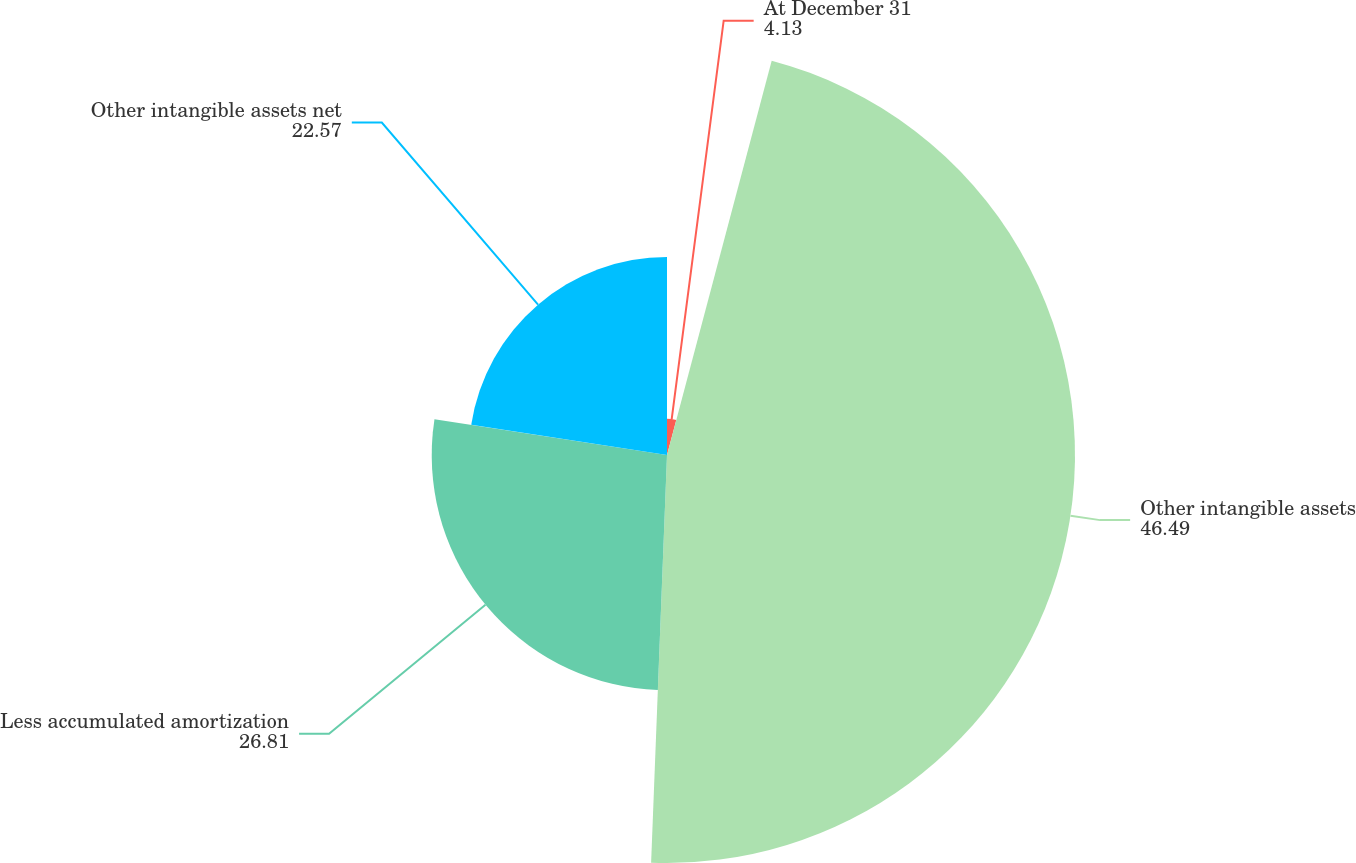Convert chart to OTSL. <chart><loc_0><loc_0><loc_500><loc_500><pie_chart><fcel>At December 31<fcel>Other intangible assets<fcel>Less accumulated amortization<fcel>Other intangible assets net<nl><fcel>4.13%<fcel>46.49%<fcel>26.81%<fcel>22.57%<nl></chart> 